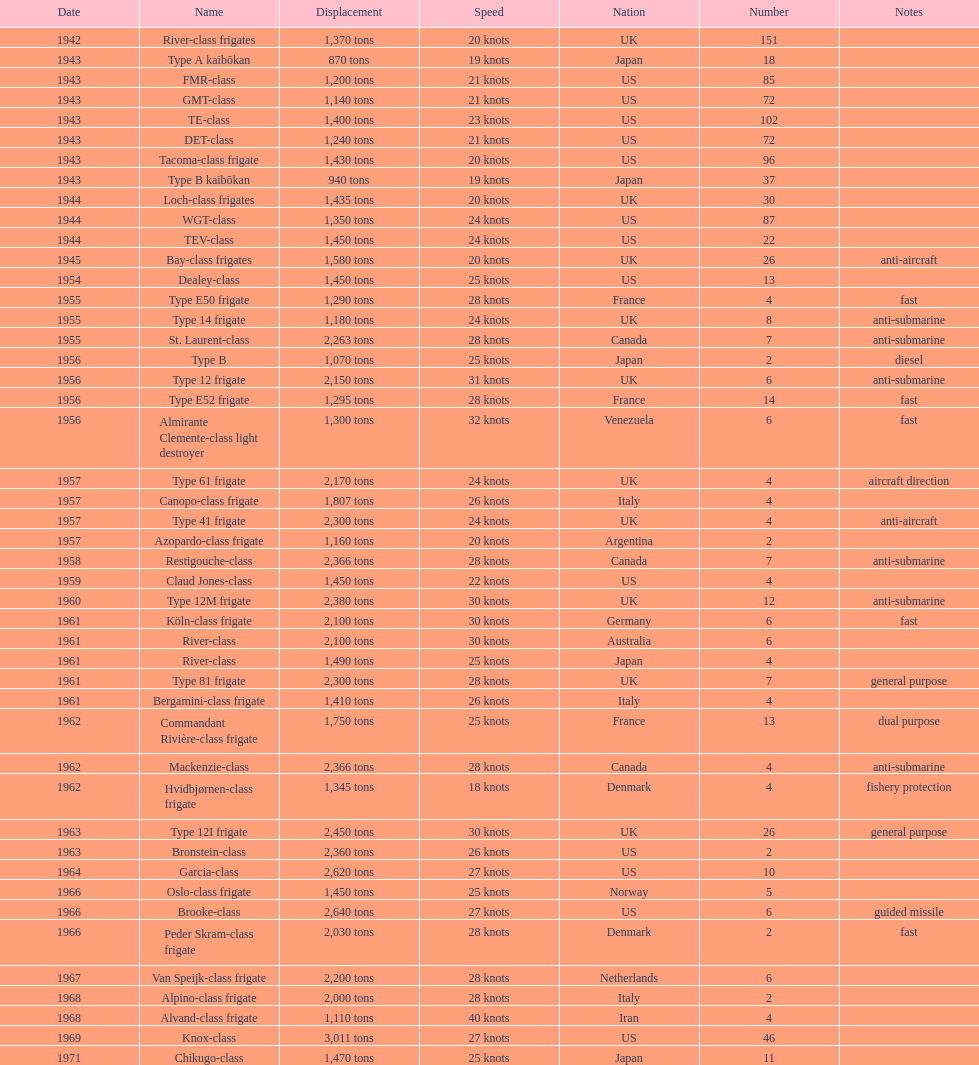Which of the boats listed is the fastest? Alvand-class frigate. Could you help me parse every detail presented in this table? {'header': ['Date', 'Name', 'Displacement', 'Speed', 'Nation', 'Number', 'Notes'], 'rows': [['1942', 'River-class frigates', '1,370 tons', '20 knots', 'UK', '151', ''], ['1943', 'Type A kaibōkan', '870 tons', '19 knots', 'Japan', '18', ''], ['1943', 'FMR-class', '1,200 tons', '21 knots', 'US', '85', ''], ['1943', 'GMT-class', '1,140 tons', '21 knots', 'US', '72', ''], ['1943', 'TE-class', '1,400 tons', '23 knots', 'US', '102', ''], ['1943', 'DET-class', '1,240 tons', '21 knots', 'US', '72', ''], ['1943', 'Tacoma-class frigate', '1,430 tons', '20 knots', 'US', '96', ''], ['1943', 'Type B kaibōkan', '940 tons', '19 knots', 'Japan', '37', ''], ['1944', 'Loch-class frigates', '1,435 tons', '20 knots', 'UK', '30', ''], ['1944', 'WGT-class', '1,350 tons', '24 knots', 'US', '87', ''], ['1944', 'TEV-class', '1,450 tons', '24 knots', 'US', '22', ''], ['1945', 'Bay-class frigates', '1,580 tons', '20 knots', 'UK', '26', 'anti-aircraft'], ['1954', 'Dealey-class', '1,450 tons', '25 knots', 'US', '13', ''], ['1955', 'Type E50 frigate', '1,290 tons', '28 knots', 'France', '4', 'fast'], ['1955', 'Type 14 frigate', '1,180 tons', '24 knots', 'UK', '8', 'anti-submarine'], ['1955', 'St. Laurent-class', '2,263 tons', '28 knots', 'Canada', '7', 'anti-submarine'], ['1956', 'Type B', '1,070 tons', '25 knots', 'Japan', '2', 'diesel'], ['1956', 'Type 12 frigate', '2,150 tons', '31 knots', 'UK', '6', 'anti-submarine'], ['1956', 'Type E52 frigate', '1,295 tons', '28 knots', 'France', '14', 'fast'], ['1956', 'Almirante Clemente-class light destroyer', '1,300 tons', '32 knots', 'Venezuela', '6', 'fast'], ['1957', 'Type 61 frigate', '2,170 tons', '24 knots', 'UK', '4', 'aircraft direction'], ['1957', 'Canopo-class frigate', '1,807 tons', '26 knots', 'Italy', '4', ''], ['1957', 'Type 41 frigate', '2,300 tons', '24 knots', 'UK', '4', 'anti-aircraft'], ['1957', 'Azopardo-class frigate', '1,160 tons', '20 knots', 'Argentina', '2', ''], ['1958', 'Restigouche-class', '2,366 tons', '28 knots', 'Canada', '7', 'anti-submarine'], ['1959', 'Claud Jones-class', '1,450 tons', '22 knots', 'US', '4', ''], ['1960', 'Type 12M frigate', '2,380 tons', '30 knots', 'UK', '12', 'anti-submarine'], ['1961', 'Köln-class frigate', '2,100 tons', '30 knots', 'Germany', '6', 'fast'], ['1961', 'River-class', '2,100 tons', '30 knots', 'Australia', '6', ''], ['1961', 'River-class', '1,490 tons', '25 knots', 'Japan', '4', ''], ['1961', 'Type 81 frigate', '2,300 tons', '28 knots', 'UK', '7', 'general purpose'], ['1961', 'Bergamini-class frigate', '1,410 tons', '26 knots', 'Italy', '4', ''], ['1962', 'Commandant Rivière-class frigate', '1,750 tons', '25 knots', 'France', '13', 'dual purpose'], ['1962', 'Mackenzie-class', '2,366 tons', '28 knots', 'Canada', '4', 'anti-submarine'], ['1962', 'Hvidbjørnen-class frigate', '1,345 tons', '18 knots', 'Denmark', '4', 'fishery protection'], ['1963', 'Type 12I frigate', '2,450 tons', '30 knots', 'UK', '26', 'general purpose'], ['1963', 'Bronstein-class', '2,360 tons', '26 knots', 'US', '2', ''], ['1964', 'Garcia-class', '2,620 tons', '27 knots', 'US', '10', ''], ['1966', 'Oslo-class frigate', '1,450 tons', '25 knots', 'Norway', '5', ''], ['1966', 'Brooke-class', '2,640 tons', '27 knots', 'US', '6', 'guided missile'], ['1966', 'Peder Skram-class frigate', '2,030 tons', '28 knots', 'Denmark', '2', 'fast'], ['1967', 'Van Speijk-class frigate', '2,200 tons', '28 knots', 'Netherlands', '6', ''], ['1968', 'Alpino-class frigate', '2,000 tons', '28 knots', 'Italy', '2', ''], ['1968', 'Alvand-class frigate', '1,110 tons', '40 knots', 'Iran', '4', ''], ['1969', 'Knox-class', '3,011 tons', '27 knots', 'US', '46', ''], ['1971', 'Chikugo-class', '1,470 tons', '25 knots', 'Japan', '11', '']]} 